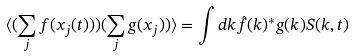Convert formula to latex. <formula><loc_0><loc_0><loc_500><loc_500>\langle ( \sum _ { j } f ( x _ { j } ( t ) ) ) ( \sum _ { j } g ( x _ { j } ) ) \rangle = \int d k \hat { f } ( k ) ^ { * } g ( k ) S ( k , t )</formula> 